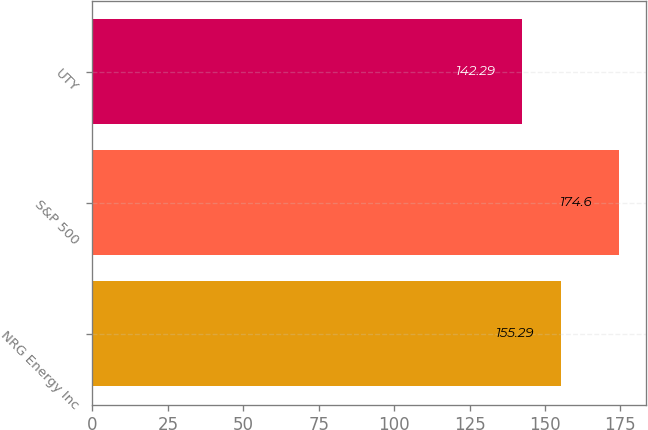<chart> <loc_0><loc_0><loc_500><loc_500><bar_chart><fcel>NRG Energy Inc<fcel>S&P 500<fcel>UTY<nl><fcel>155.29<fcel>174.6<fcel>142.29<nl></chart> 